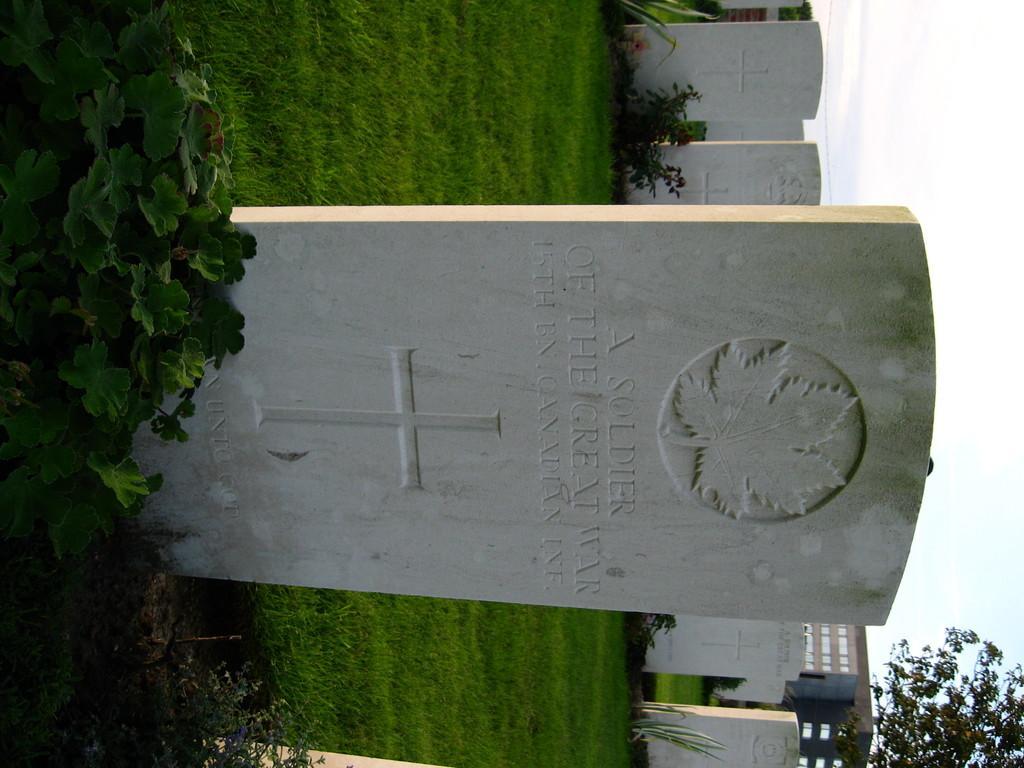Describe this image in one or two sentences. In this image there are headstones, plants, grass, building, tree, and in the background there is sky. 